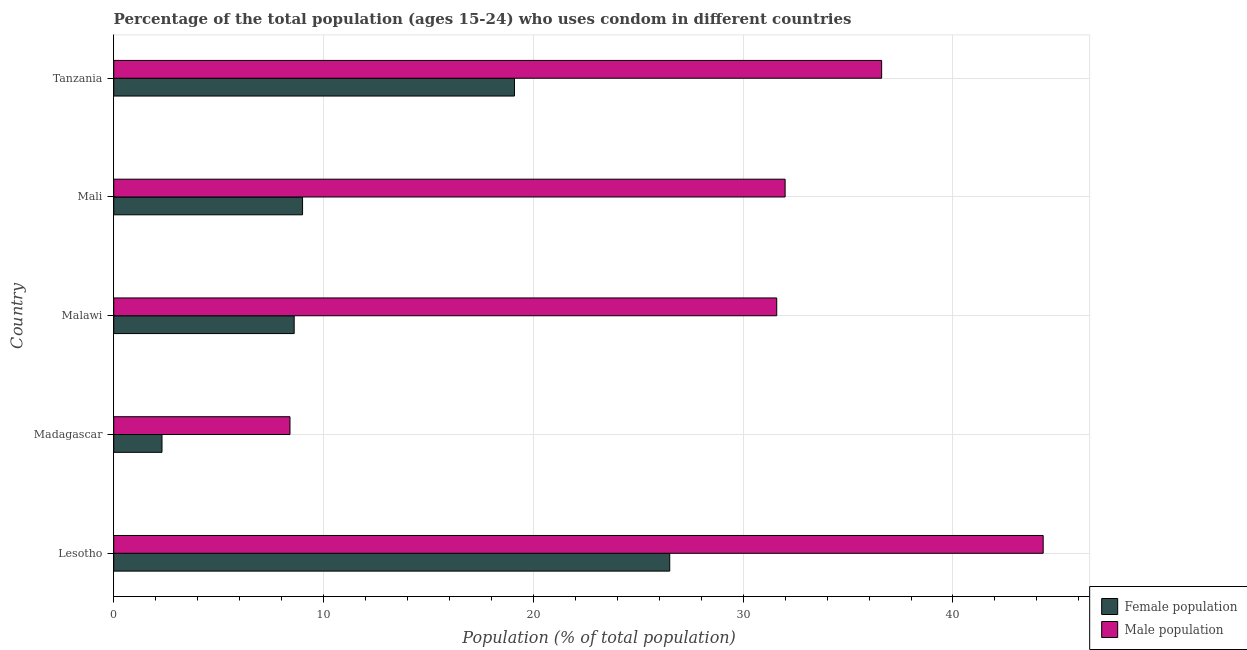How many groups of bars are there?
Give a very brief answer. 5. How many bars are there on the 5th tick from the top?
Offer a very short reply. 2. How many bars are there on the 1st tick from the bottom?
Keep it short and to the point. 2. What is the label of the 5th group of bars from the top?
Your answer should be compact. Lesotho. Across all countries, what is the maximum male population?
Make the answer very short. 44.3. In which country was the male population maximum?
Provide a succinct answer. Lesotho. In which country was the male population minimum?
Your answer should be very brief. Madagascar. What is the total male population in the graph?
Provide a short and direct response. 152.9. What is the difference between the male population in Malawi and that in Mali?
Your answer should be compact. -0.4. What is the difference between the male population in Mali and the female population in Madagascar?
Ensure brevity in your answer.  29.7. What is the difference between the male population and female population in Lesotho?
Provide a short and direct response. 17.8. Is the male population in Lesotho less than that in Madagascar?
Your response must be concise. No. Is the difference between the male population in Lesotho and Mali greater than the difference between the female population in Lesotho and Mali?
Provide a succinct answer. No. What is the difference between the highest and the second highest female population?
Offer a terse response. 7.4. What is the difference between the highest and the lowest male population?
Make the answer very short. 35.9. What does the 1st bar from the top in Lesotho represents?
Give a very brief answer. Male population. What does the 1st bar from the bottom in Lesotho represents?
Offer a terse response. Female population. Are all the bars in the graph horizontal?
Your answer should be very brief. Yes. Does the graph contain any zero values?
Give a very brief answer. No. Where does the legend appear in the graph?
Your answer should be compact. Bottom right. What is the title of the graph?
Your response must be concise. Percentage of the total population (ages 15-24) who uses condom in different countries. What is the label or title of the X-axis?
Your answer should be compact. Population (% of total population) . What is the label or title of the Y-axis?
Offer a very short reply. Country. What is the Population (% of total population)  of Female population in Lesotho?
Provide a short and direct response. 26.5. What is the Population (% of total population)  of Male population in Lesotho?
Offer a terse response. 44.3. What is the Population (% of total population)  of Male population in Madagascar?
Provide a succinct answer. 8.4. What is the Population (% of total population)  of Male population in Malawi?
Your answer should be compact. 31.6. What is the Population (% of total population)  in Male population in Tanzania?
Give a very brief answer. 36.6. Across all countries, what is the maximum Population (% of total population)  of Female population?
Your response must be concise. 26.5. Across all countries, what is the maximum Population (% of total population)  of Male population?
Your answer should be very brief. 44.3. What is the total Population (% of total population)  in Female population in the graph?
Offer a terse response. 65.5. What is the total Population (% of total population)  in Male population in the graph?
Your response must be concise. 152.9. What is the difference between the Population (% of total population)  in Female population in Lesotho and that in Madagascar?
Offer a terse response. 24.2. What is the difference between the Population (% of total population)  in Male population in Lesotho and that in Madagascar?
Your answer should be very brief. 35.9. What is the difference between the Population (% of total population)  in Female population in Lesotho and that in Mali?
Provide a succinct answer. 17.5. What is the difference between the Population (% of total population)  of Female population in Lesotho and that in Tanzania?
Provide a succinct answer. 7.4. What is the difference between the Population (% of total population)  in Male population in Lesotho and that in Tanzania?
Offer a terse response. 7.7. What is the difference between the Population (% of total population)  of Female population in Madagascar and that in Malawi?
Ensure brevity in your answer.  -6.3. What is the difference between the Population (% of total population)  in Male population in Madagascar and that in Malawi?
Provide a succinct answer. -23.2. What is the difference between the Population (% of total population)  in Male population in Madagascar and that in Mali?
Provide a succinct answer. -23.6. What is the difference between the Population (% of total population)  of Female population in Madagascar and that in Tanzania?
Your answer should be compact. -16.8. What is the difference between the Population (% of total population)  of Male population in Madagascar and that in Tanzania?
Your answer should be compact. -28.2. What is the difference between the Population (% of total population)  of Female population in Malawi and that in Mali?
Offer a terse response. -0.4. What is the difference between the Population (% of total population)  in Male population in Malawi and that in Mali?
Give a very brief answer. -0.4. What is the difference between the Population (% of total population)  of Male population in Malawi and that in Tanzania?
Make the answer very short. -5. What is the difference between the Population (% of total population)  in Female population in Lesotho and the Population (% of total population)  in Male population in Mali?
Provide a short and direct response. -5.5. What is the difference between the Population (% of total population)  of Female population in Lesotho and the Population (% of total population)  of Male population in Tanzania?
Your response must be concise. -10.1. What is the difference between the Population (% of total population)  in Female population in Madagascar and the Population (% of total population)  in Male population in Malawi?
Offer a very short reply. -29.3. What is the difference between the Population (% of total population)  of Female population in Madagascar and the Population (% of total population)  of Male population in Mali?
Ensure brevity in your answer.  -29.7. What is the difference between the Population (% of total population)  in Female population in Madagascar and the Population (% of total population)  in Male population in Tanzania?
Your answer should be compact. -34.3. What is the difference between the Population (% of total population)  in Female population in Malawi and the Population (% of total population)  in Male population in Mali?
Give a very brief answer. -23.4. What is the difference between the Population (% of total population)  in Female population in Malawi and the Population (% of total population)  in Male population in Tanzania?
Your answer should be compact. -28. What is the difference between the Population (% of total population)  of Female population in Mali and the Population (% of total population)  of Male population in Tanzania?
Your answer should be very brief. -27.6. What is the average Population (% of total population)  of Male population per country?
Your answer should be very brief. 30.58. What is the difference between the Population (% of total population)  of Female population and Population (% of total population)  of Male population in Lesotho?
Your response must be concise. -17.8. What is the difference between the Population (% of total population)  in Female population and Population (% of total population)  in Male population in Madagascar?
Offer a very short reply. -6.1. What is the difference between the Population (% of total population)  in Female population and Population (% of total population)  in Male population in Mali?
Make the answer very short. -23. What is the difference between the Population (% of total population)  of Female population and Population (% of total population)  of Male population in Tanzania?
Your response must be concise. -17.5. What is the ratio of the Population (% of total population)  of Female population in Lesotho to that in Madagascar?
Your response must be concise. 11.52. What is the ratio of the Population (% of total population)  in Male population in Lesotho to that in Madagascar?
Keep it short and to the point. 5.27. What is the ratio of the Population (% of total population)  in Female population in Lesotho to that in Malawi?
Your response must be concise. 3.08. What is the ratio of the Population (% of total population)  of Male population in Lesotho to that in Malawi?
Offer a terse response. 1.4. What is the ratio of the Population (% of total population)  in Female population in Lesotho to that in Mali?
Give a very brief answer. 2.94. What is the ratio of the Population (% of total population)  in Male population in Lesotho to that in Mali?
Provide a short and direct response. 1.38. What is the ratio of the Population (% of total population)  in Female population in Lesotho to that in Tanzania?
Your answer should be compact. 1.39. What is the ratio of the Population (% of total population)  in Male population in Lesotho to that in Tanzania?
Your response must be concise. 1.21. What is the ratio of the Population (% of total population)  in Female population in Madagascar to that in Malawi?
Provide a short and direct response. 0.27. What is the ratio of the Population (% of total population)  of Male population in Madagascar to that in Malawi?
Keep it short and to the point. 0.27. What is the ratio of the Population (% of total population)  in Female population in Madagascar to that in Mali?
Offer a terse response. 0.26. What is the ratio of the Population (% of total population)  in Male population in Madagascar to that in Mali?
Ensure brevity in your answer.  0.26. What is the ratio of the Population (% of total population)  of Female population in Madagascar to that in Tanzania?
Provide a short and direct response. 0.12. What is the ratio of the Population (% of total population)  of Male population in Madagascar to that in Tanzania?
Provide a succinct answer. 0.23. What is the ratio of the Population (% of total population)  of Female population in Malawi to that in Mali?
Keep it short and to the point. 0.96. What is the ratio of the Population (% of total population)  in Male population in Malawi to that in Mali?
Give a very brief answer. 0.99. What is the ratio of the Population (% of total population)  in Female population in Malawi to that in Tanzania?
Offer a terse response. 0.45. What is the ratio of the Population (% of total population)  of Male population in Malawi to that in Tanzania?
Make the answer very short. 0.86. What is the ratio of the Population (% of total population)  of Female population in Mali to that in Tanzania?
Offer a terse response. 0.47. What is the ratio of the Population (% of total population)  of Male population in Mali to that in Tanzania?
Your answer should be very brief. 0.87. What is the difference between the highest and the second highest Population (% of total population)  of Female population?
Ensure brevity in your answer.  7.4. What is the difference between the highest and the lowest Population (% of total population)  of Female population?
Your answer should be compact. 24.2. What is the difference between the highest and the lowest Population (% of total population)  in Male population?
Provide a succinct answer. 35.9. 